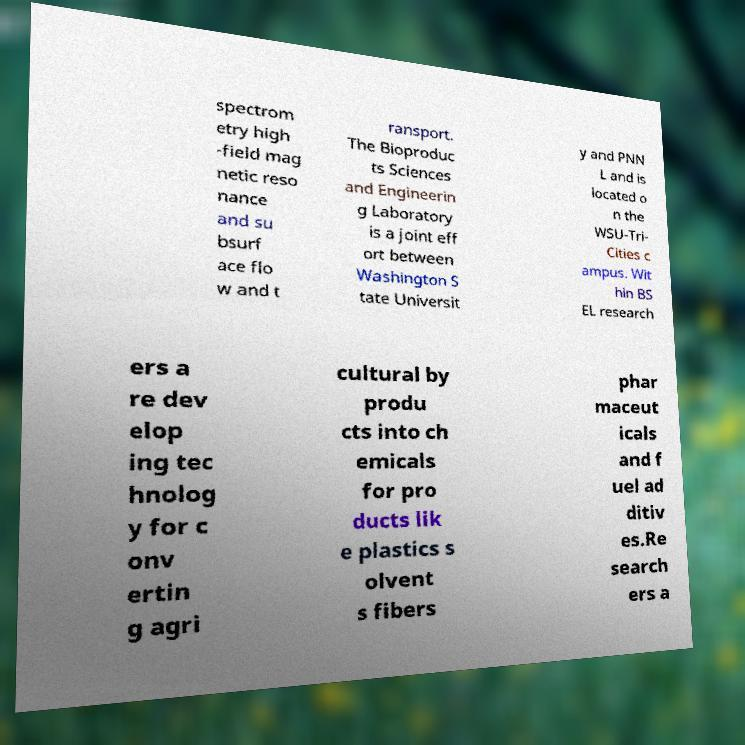Please read and relay the text visible in this image. What does it say? spectrom etry high -field mag netic reso nance and su bsurf ace flo w and t ransport. The Bioproduc ts Sciences and Engineerin g Laboratory is a joint eff ort between Washington S tate Universit y and PNN L and is located o n the WSU-Tri- Cities c ampus. Wit hin BS EL research ers a re dev elop ing tec hnolog y for c onv ertin g agri cultural by produ cts into ch emicals for pro ducts lik e plastics s olvent s fibers phar maceut icals and f uel ad ditiv es.Re search ers a 